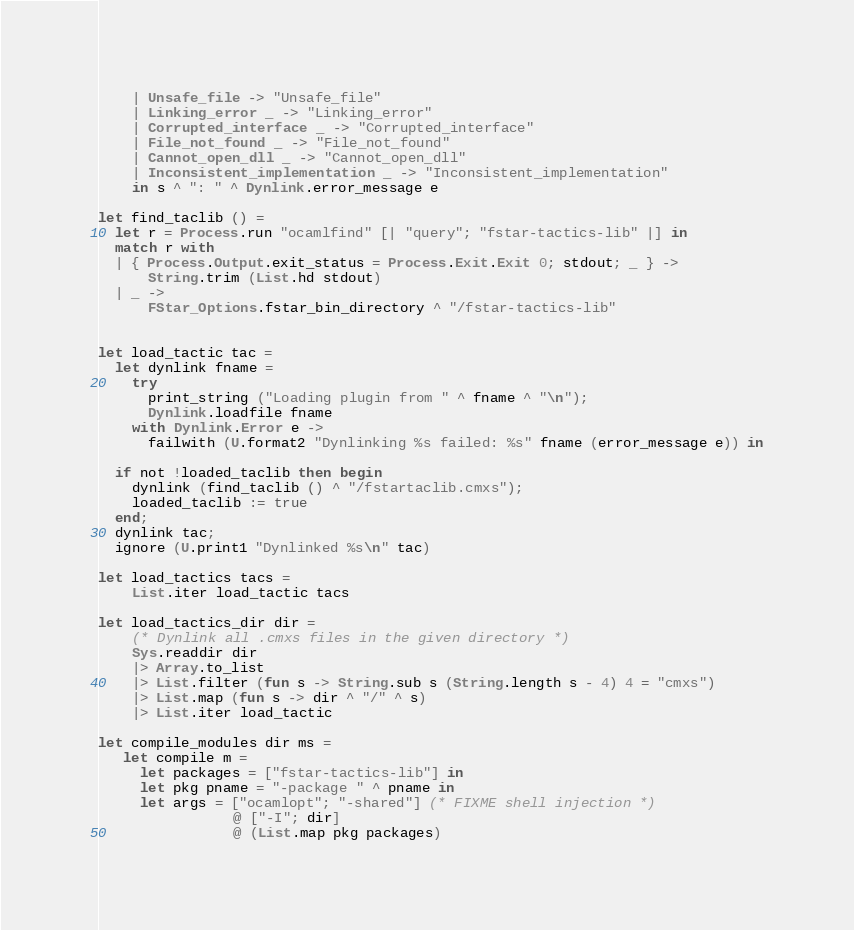Convert code to text. <code><loc_0><loc_0><loc_500><loc_500><_OCaml_>    | Unsafe_file -> "Unsafe_file"
    | Linking_error _ -> "Linking_error"
    | Corrupted_interface _ -> "Corrupted_interface"
    | File_not_found _ -> "File_not_found"
    | Cannot_open_dll _ -> "Cannot_open_dll"
    | Inconsistent_implementation _ -> "Inconsistent_implementation"
    in s ^ ": " ^ Dynlink.error_message e

let find_taclib () =
  let r = Process.run "ocamlfind" [| "query"; "fstar-tactics-lib" |] in
  match r with
  | { Process.Output.exit_status = Process.Exit.Exit 0; stdout; _ } ->
      String.trim (List.hd stdout)
  | _ ->
      FStar_Options.fstar_bin_directory ^ "/fstar-tactics-lib"


let load_tactic tac =
  let dynlink fname =
    try
      print_string ("Loading plugin from " ^ fname ^ "\n");
      Dynlink.loadfile fname
    with Dynlink.Error e ->
      failwith (U.format2 "Dynlinking %s failed: %s" fname (error_message e)) in

  if not !loaded_taclib then begin
    dynlink (find_taclib () ^ "/fstartaclib.cmxs");
    loaded_taclib := true
  end;
  dynlink tac;
  ignore (U.print1 "Dynlinked %s\n" tac)

let load_tactics tacs =
    List.iter load_tactic tacs

let load_tactics_dir dir =
    (* Dynlink all .cmxs files in the given directory *)
    Sys.readdir dir
    |> Array.to_list
    |> List.filter (fun s -> String.sub s (String.length s - 4) 4 = "cmxs")
    |> List.map (fun s -> dir ^ "/" ^ s)
    |> List.iter load_tactic

let compile_modules dir ms =
   let compile m =
     let packages = ["fstar-tactics-lib"] in
     let pkg pname = "-package " ^ pname in
     let args = ["ocamlopt"; "-shared"] (* FIXME shell injection *)
                @ ["-I"; dir]
                @ (List.map pkg packages)</code> 